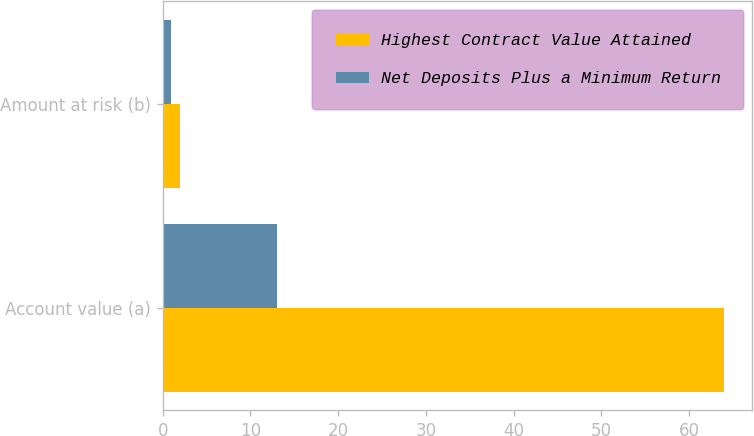Convert chart to OTSL. <chart><loc_0><loc_0><loc_500><loc_500><stacked_bar_chart><ecel><fcel>Account value (a)<fcel>Amount at risk (b)<nl><fcel>Highest Contract Value Attained<fcel>64<fcel>2<nl><fcel>Net Deposits Plus a Minimum Return<fcel>13<fcel>1<nl></chart> 